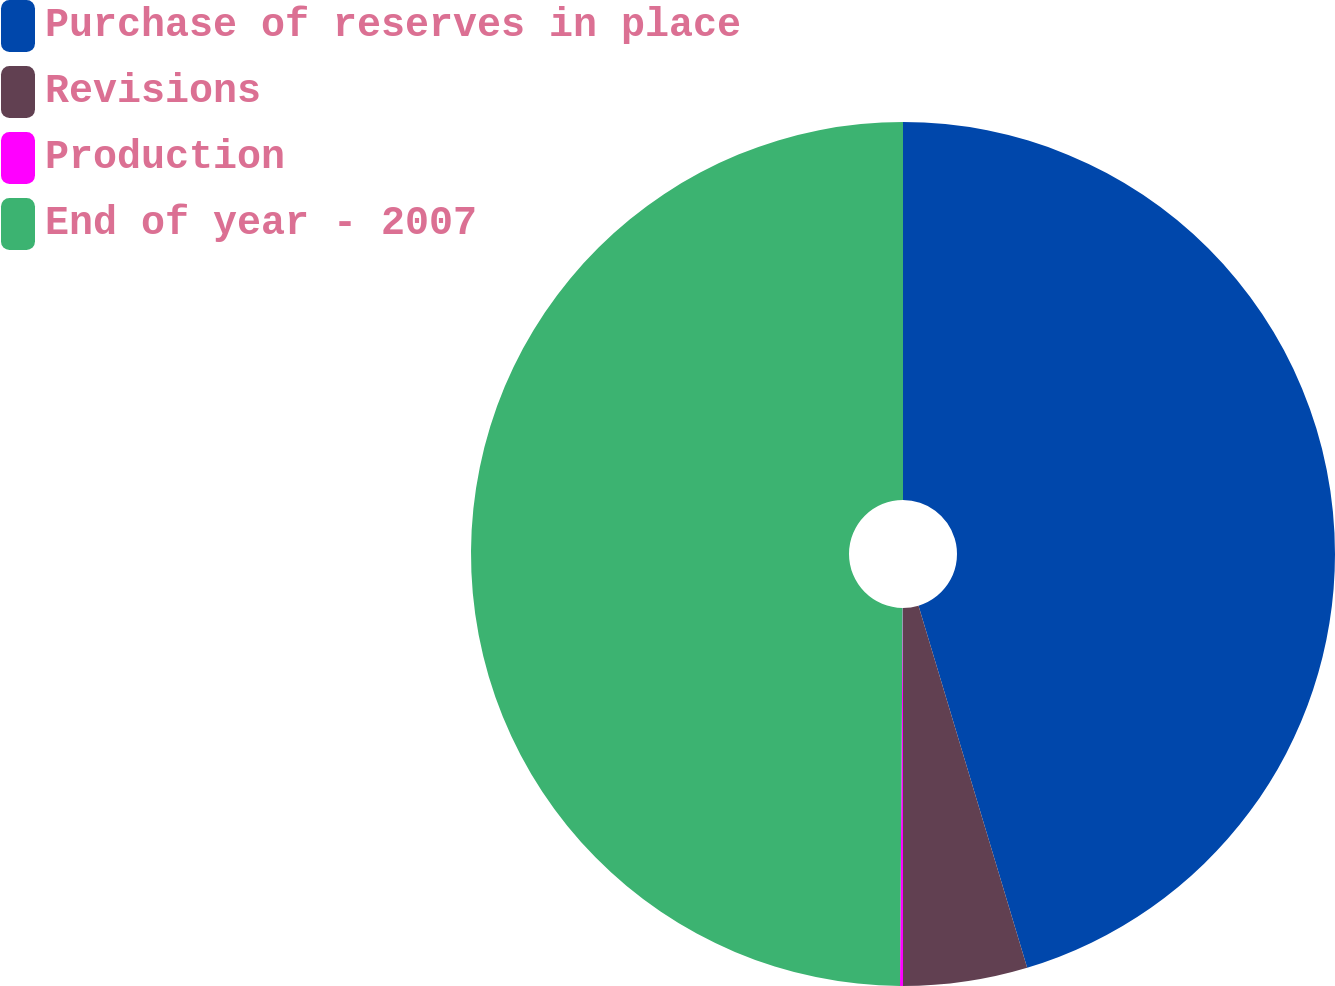Convert chart to OTSL. <chart><loc_0><loc_0><loc_500><loc_500><pie_chart><fcel>Purchase of reserves in place<fcel>Revisions<fcel>Production<fcel>End of year - 2007<nl><fcel>45.36%<fcel>4.64%<fcel>0.11%<fcel>49.89%<nl></chart> 